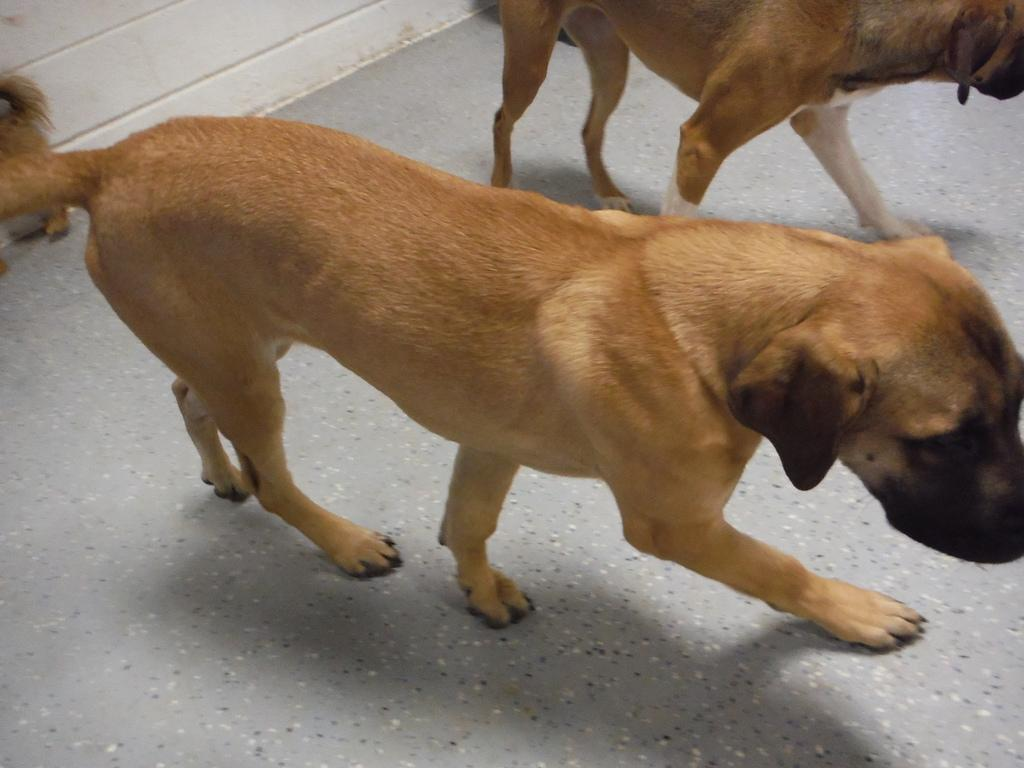What type of animal is present in the image? There is a dog in the image. Can you describe the color of the dog? The dog is brown in color. Are there any other dogs in the image? Yes, there is another dog in the image. Where is the second dog located in the image? The second dog is at the top of the image. What type of lace can be seen on the dog's collar in the image? There is no mention of lace or a collar in the image. The image only shows two dogs, one brown and the other at the top of the image. 